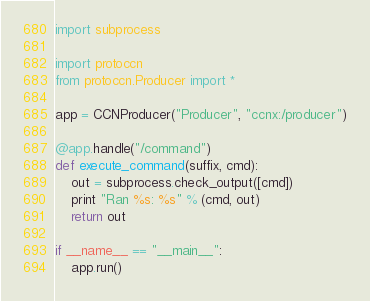Convert code to text. <code><loc_0><loc_0><loc_500><loc_500><_Python_>import subprocess

import protoccn
from protoccn.Producer import *

app = CCNProducer("Producer", "ccnx:/producer")

@app.handle("/command")
def execute_command(suffix, cmd):
    out = subprocess.check_output([cmd])
    print "Ran %s: %s" % (cmd, out)
    return out

if __name__ == "__main__":
    app.run()
</code> 